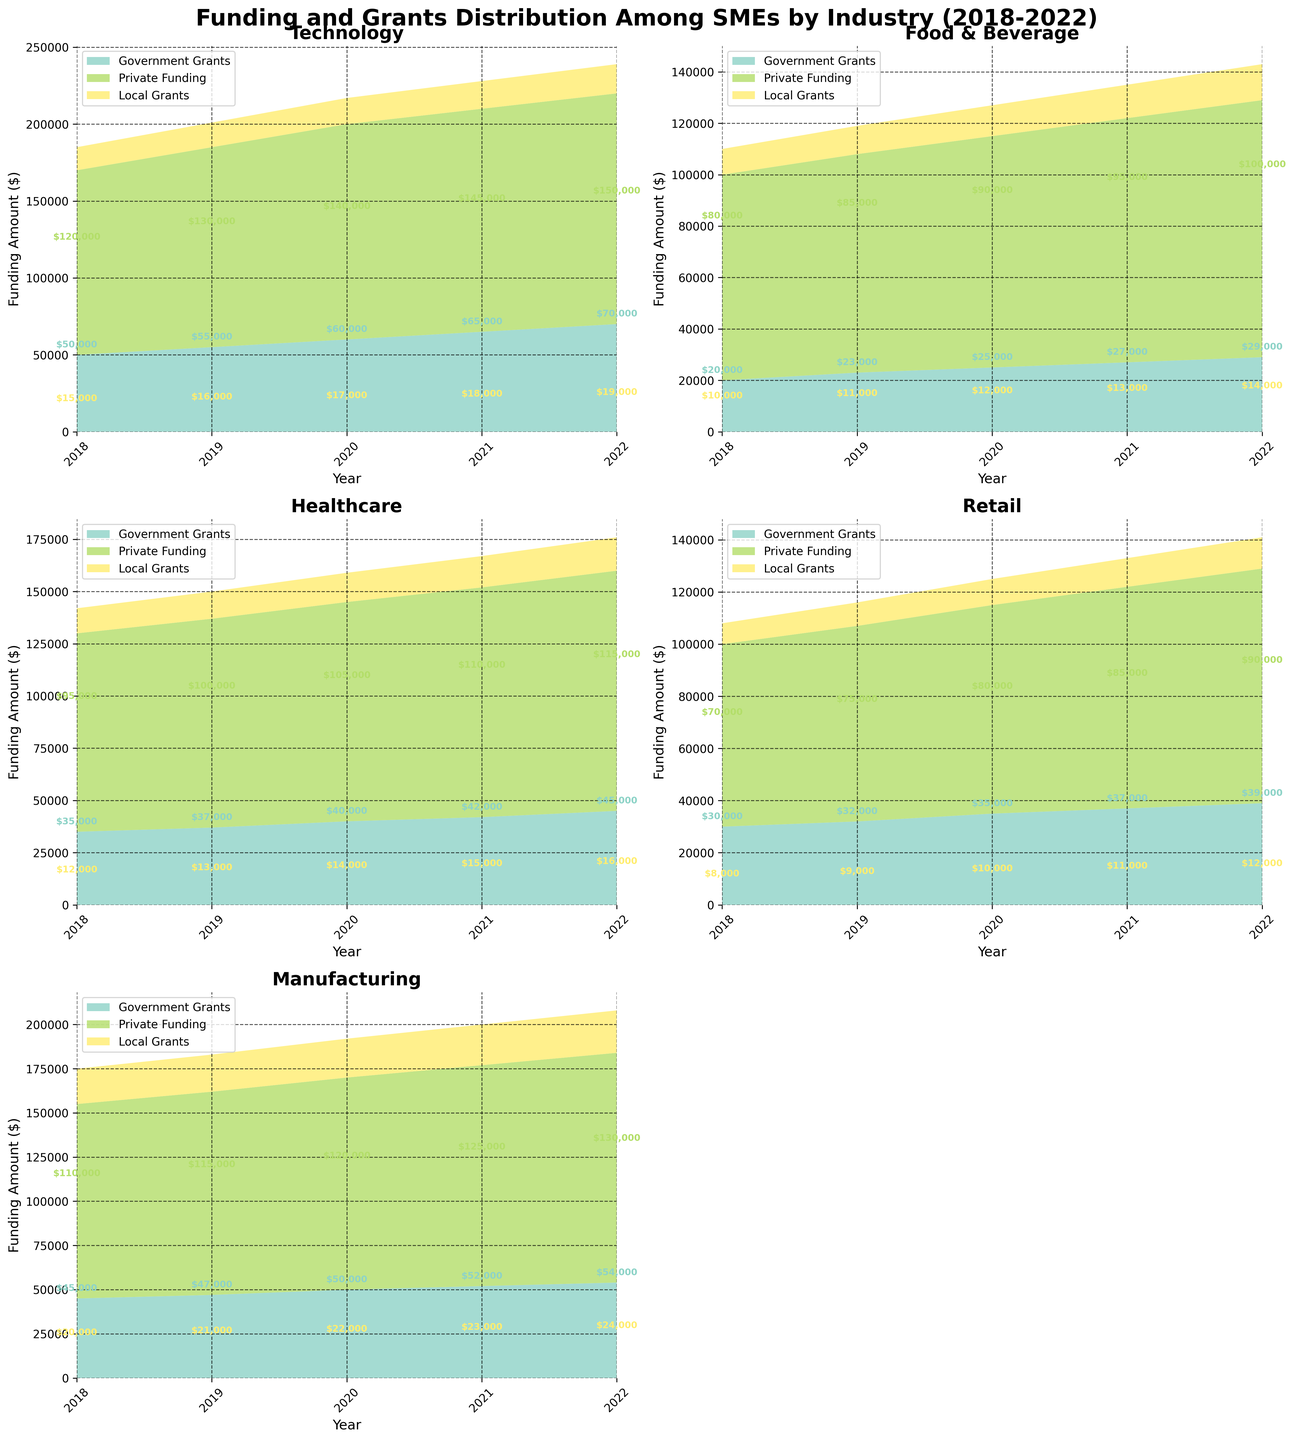What is the total amount of Government Grants received by the Technology industry in 2019? Look at the Technology industry's area chart and locate the value for Government Grants in 2019, which is $55,000
Answer: $55,000 Which industry received the most Private Funding in 2021? Compare the Private Funding values across all industries in 2021. Technology received the most with $145,000
Answer: Technology How much did Local Grants for the Manufacturing industry increase from 2019 to 2020? Find the values for Local Grants in Manufacturing for 2019 ($21,000) and 2020 ($22,000). Subtract $21,000 from $22,000 to get the increase, which is $1,000
Answer: $1,000 What is the overall trend of Government Grants for the Healthcare industry from 2018 to 2022? Observe the Government Grants area in the Healthcare industry subplot. It increased from $35,000 in 2018 to $45,000 in 2022, showing an upward trend
Answer: Increasing What is the difference between Private Funding and Local Grants for the Retail industry in 2020? Locate the 2020 values for Retail: Private Funding ($80,000) and Local Grants ($10,000). Subtract Local Grants from Private Funding: $80,000 - $10,000 = $70,000
Answer: $70,000 Which industry saw the greatest increase in total funding (sum of all grants and funding types) from 2018 to 2022? Calculate the total for each industry in both years and compare the differences. Manufacturing saw the greatest increase:
2018: $175,000 (Government Grants $45,000 + Private Funding $110,000 + Local Grants $20,000);
2022: $208,000 (Government Grants $54,000 + Private Funding $130,000 + Local Grants $24,000);
Increase: $33,000
Answer: Manufacturing From 2019 to 2021, which industry experienced the largest decrease in Government Grants? Examine the Government Grants across all industries from 2019 to 2021. No industry shows a decrease in Government Grants in that period.
Answer: No decrease In 2020, what is the proportion of Government Grants to the total funding for the Food & Beverage industry? Calculate the total funding for Food & Beverage in 2020: $25,000 (Government Grants) + $90,000 (Private Funding) + $12,000 (Local Grants) = $127,000. Proportion of Government Grants is $25,000 / $127,000 ≈ 0.197 or 19.7%
Answer: 19.7% Which industry received the least amount of Local Grants in 2022? Locate the Local Grants values for all industries in 2022. Retail received the least with $12,000
Answer: Retail 